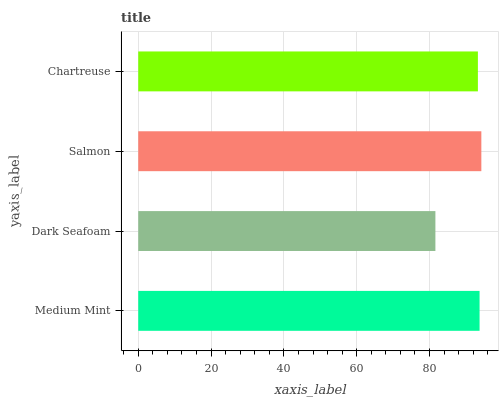Is Dark Seafoam the minimum?
Answer yes or no. Yes. Is Salmon the maximum?
Answer yes or no. Yes. Is Salmon the minimum?
Answer yes or no. No. Is Dark Seafoam the maximum?
Answer yes or no. No. Is Salmon greater than Dark Seafoam?
Answer yes or no. Yes. Is Dark Seafoam less than Salmon?
Answer yes or no. Yes. Is Dark Seafoam greater than Salmon?
Answer yes or no. No. Is Salmon less than Dark Seafoam?
Answer yes or no. No. Is Medium Mint the high median?
Answer yes or no. Yes. Is Chartreuse the low median?
Answer yes or no. Yes. Is Chartreuse the high median?
Answer yes or no. No. Is Salmon the low median?
Answer yes or no. No. 